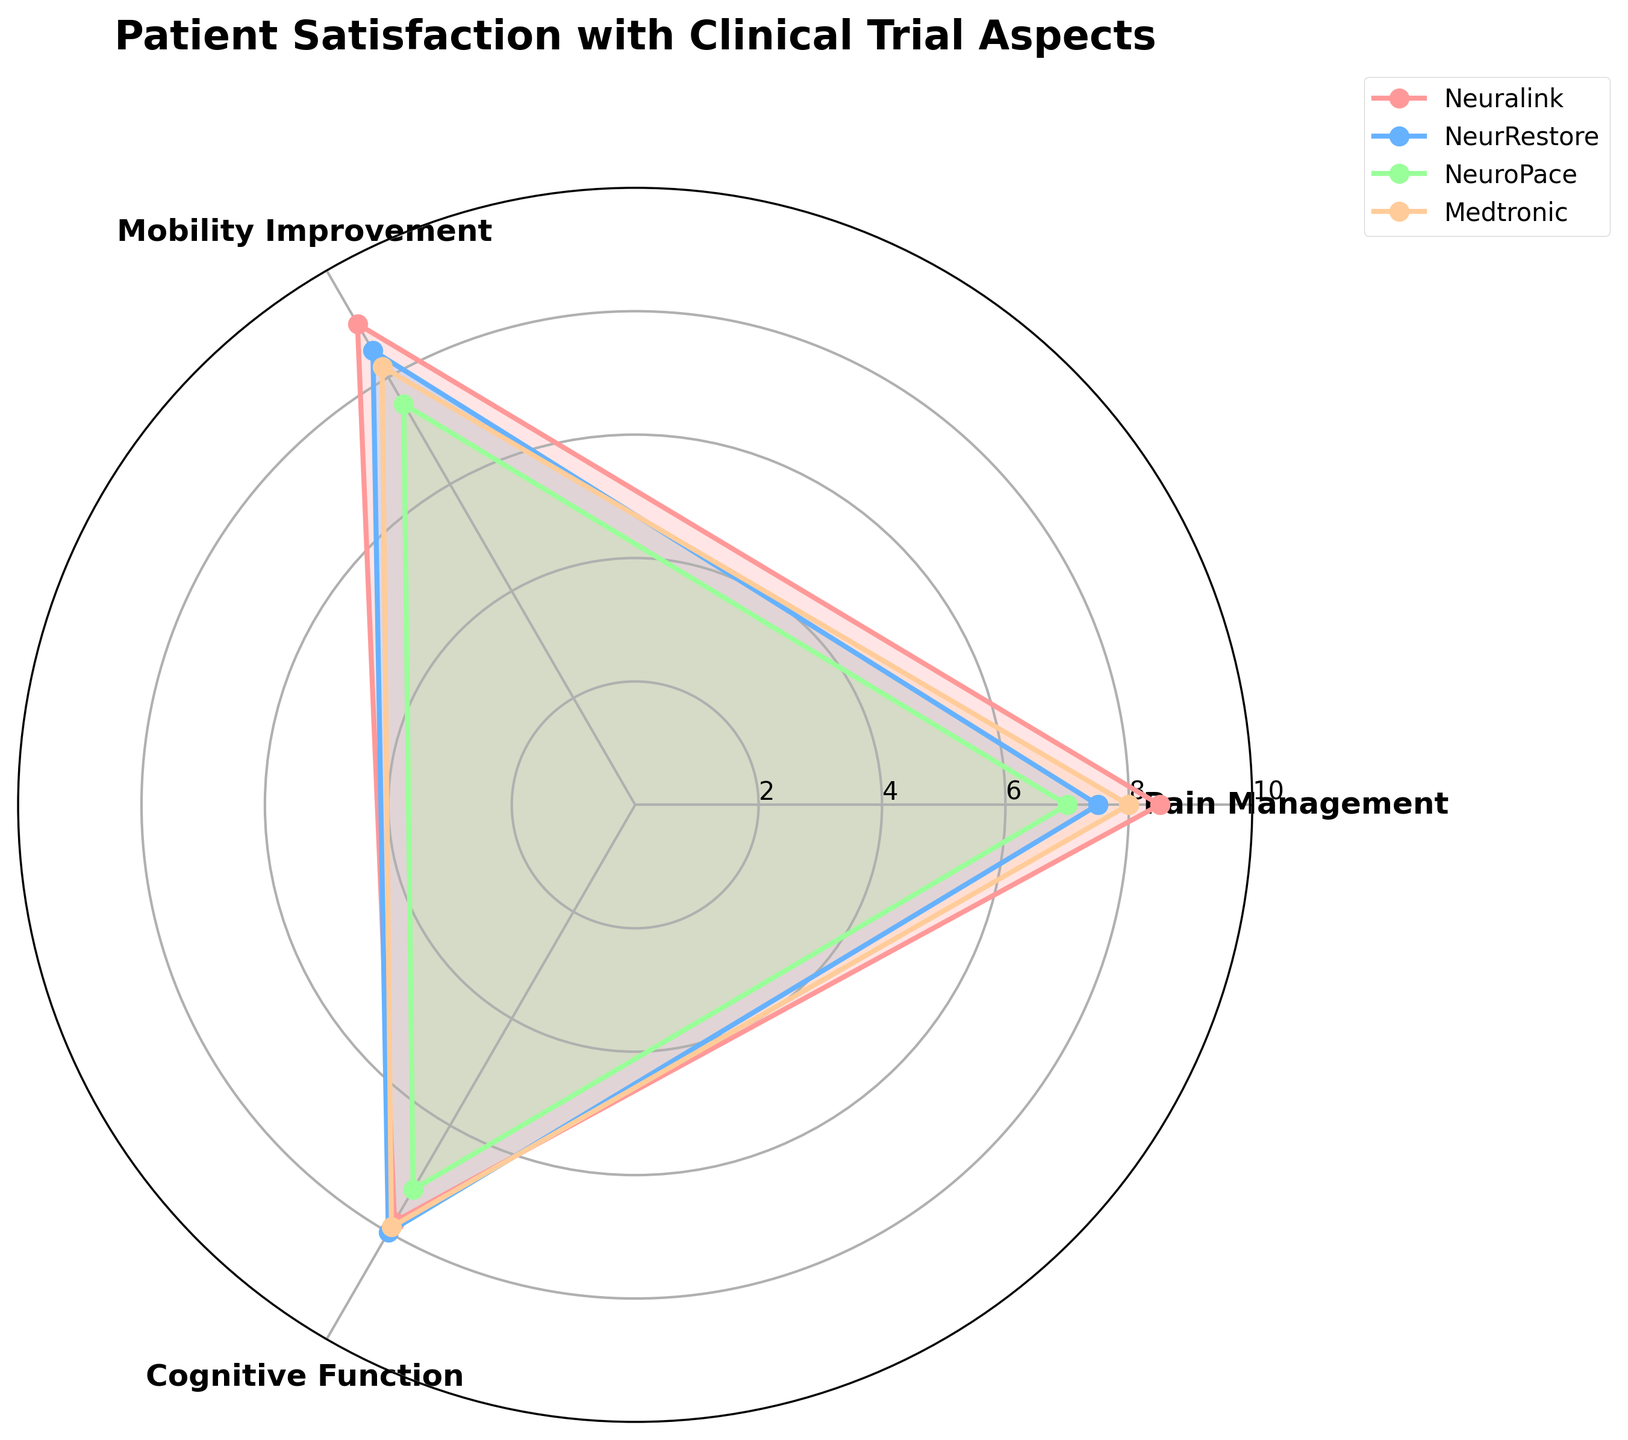Which group scored the highest in Pain Management? According to the chart, Neuralink scored the highest in Pain Management with a score of 8.5.
Answer: Neuralink Which group had the lowest score for Cognitive Function? According to the radar chart, NeuroPace had the lowest score for Cognitive Function with a score of 7.2.
Answer: NeuroPace What is the average score of Medtronic across all aspects? Medtronic’s scores are 8.0, 8.2, and 7.9 for Pain Management, Mobility Improvement, and Cognitive Function, respectively. The average is (8.0 + 8.2 + 7.9) / 3 = 8.03.
Answer: 8.03 How much higher is Neuralink’s Mobility Improvement score compared to NeuroPace’s? Neuralink scored 9.0 and NeuroPace scored 7.5 in Mobility Improvement. The difference is 9.0 - 7.5 = 1.5.
Answer: 1.5 Which two groups have the closest scores in Mobility Improvement? NeurRestore scored 8.5 and Medtronic scored 8.2 in Mobility Improvement. The difference of 0.3 is the smallest among all group score comparisons in this category.
Answer: NeurRestore and Medtronic Which aspect does NeuroPace need the most improvement in? In the radar chart, NeuroPace has the lowest score in Cognitive Function with a score of 7.2, indicating the need for most improvement in this aspect.
Answer: Cognitive Function What is the overall best performing group across all aspects? Summarize the scores of all aspects for each group and compare them. Neuralink scores 8.5 (Pain Management), 9.0 (Mobility Improvement), and 7.8 (Cognitive Function). Adding these gives 25.3. NeurRestore scores 7.5 + 8.5 + 8.0 = 24.0. NeuroPace scores 7.0 + 7.5 + 7.2 = 21.7. Medtronic scores 8.0 + 8.2 + 7.9 = 24.1. Thus, Neuralink has the highest total score.
Answer: Neuralink Which group shows the most consistency in scores across different aspects? The difference between the highest and lowest scores for each group determines consistency. Neuralink: 9.0 - 7.8 = 1.2. NeurRestore: 8.5 - 7.5 = 1.0. NeuroPace: 7.5 - 7.0 = 0.5. Medtronic: 8.2 - 7.9 = 0.3. Medtronic has the smallest difference, showing the most consistency.
Answer: Medtronic 